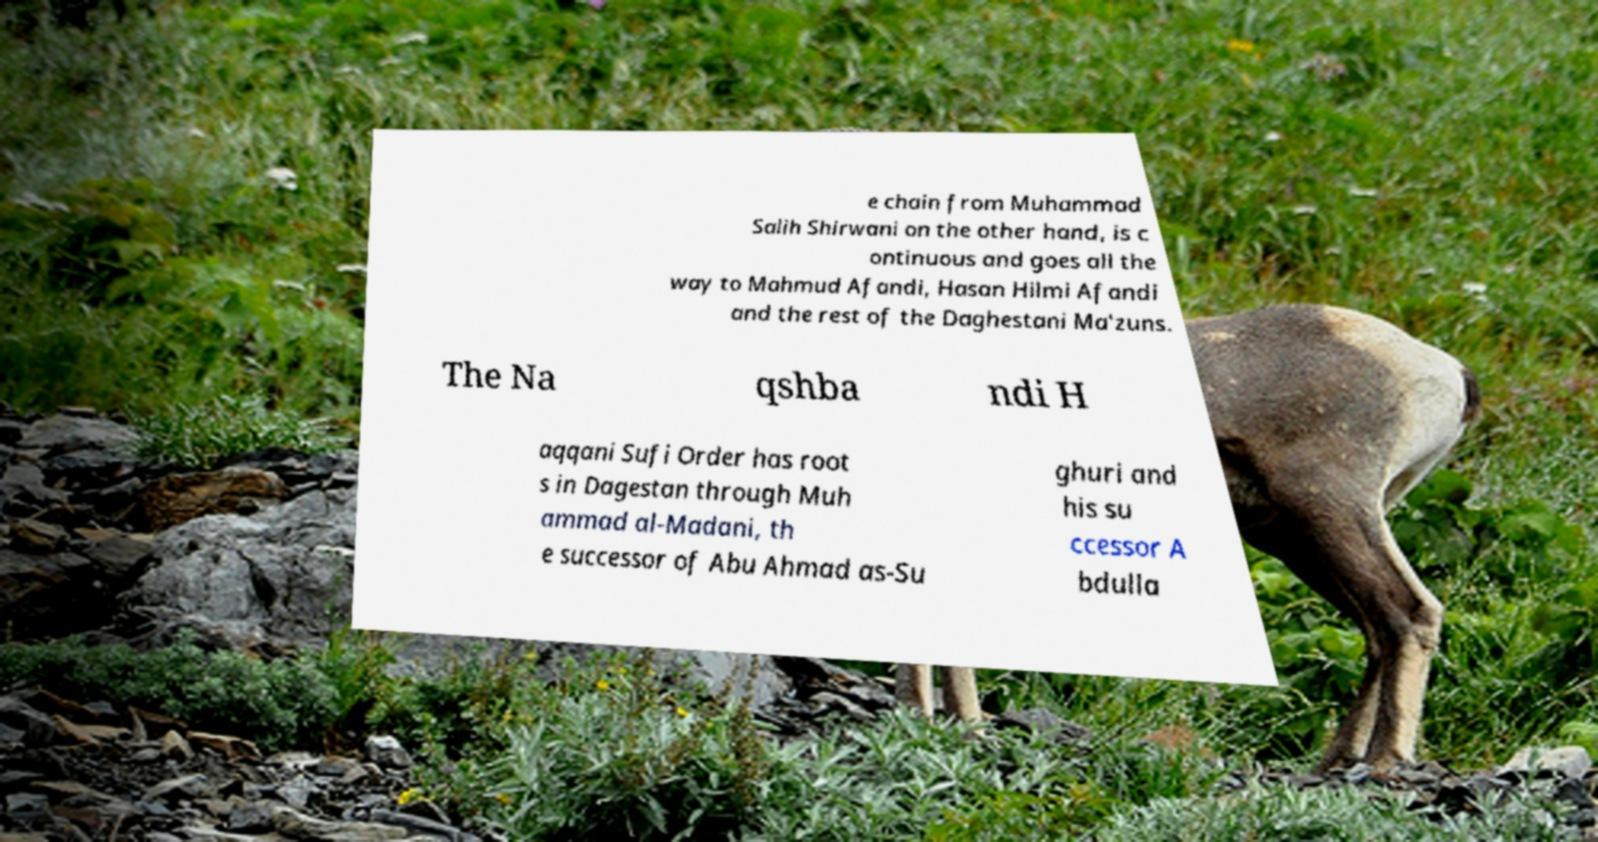Could you extract and type out the text from this image? e chain from Muhammad Salih Shirwani on the other hand, is c ontinuous and goes all the way to Mahmud Afandi, Hasan Hilmi Afandi and the rest of the Daghestani Ma'zuns. The Na qshba ndi H aqqani Sufi Order has root s in Dagestan through Muh ammad al-Madani, th e successor of Abu Ahmad as-Su ghuri and his su ccessor A bdulla 